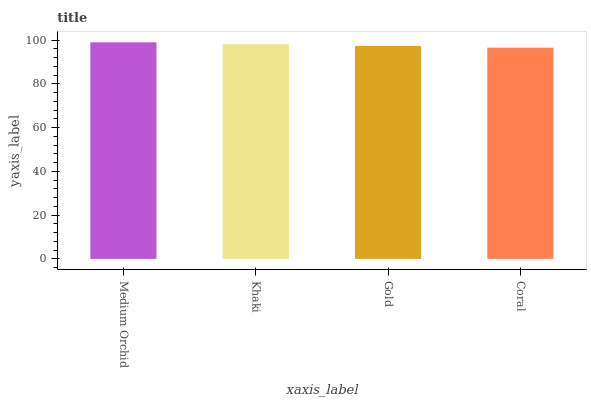Is Coral the minimum?
Answer yes or no. Yes. Is Medium Orchid the maximum?
Answer yes or no. Yes. Is Khaki the minimum?
Answer yes or no. No. Is Khaki the maximum?
Answer yes or no. No. Is Medium Orchid greater than Khaki?
Answer yes or no. Yes. Is Khaki less than Medium Orchid?
Answer yes or no. Yes. Is Khaki greater than Medium Orchid?
Answer yes or no. No. Is Medium Orchid less than Khaki?
Answer yes or no. No. Is Khaki the high median?
Answer yes or no. Yes. Is Gold the low median?
Answer yes or no. Yes. Is Medium Orchid the high median?
Answer yes or no. No. Is Coral the low median?
Answer yes or no. No. 